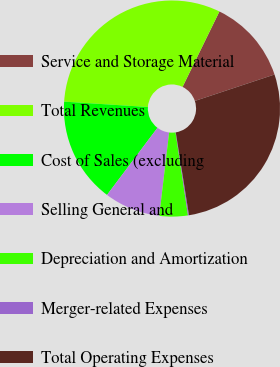<chart> <loc_0><loc_0><loc_500><loc_500><pie_chart><fcel>Service and Storage Material<fcel>Total Revenues<fcel>Cost of Sales (excluding<fcel>Selling General and<fcel>Depreciation and Amortization<fcel>Merger-related Expenses<fcel>Total Operating Expenses<nl><fcel>12.66%<fcel>31.22%<fcel>15.76%<fcel>8.38%<fcel>4.25%<fcel>0.15%<fcel>27.58%<nl></chart> 